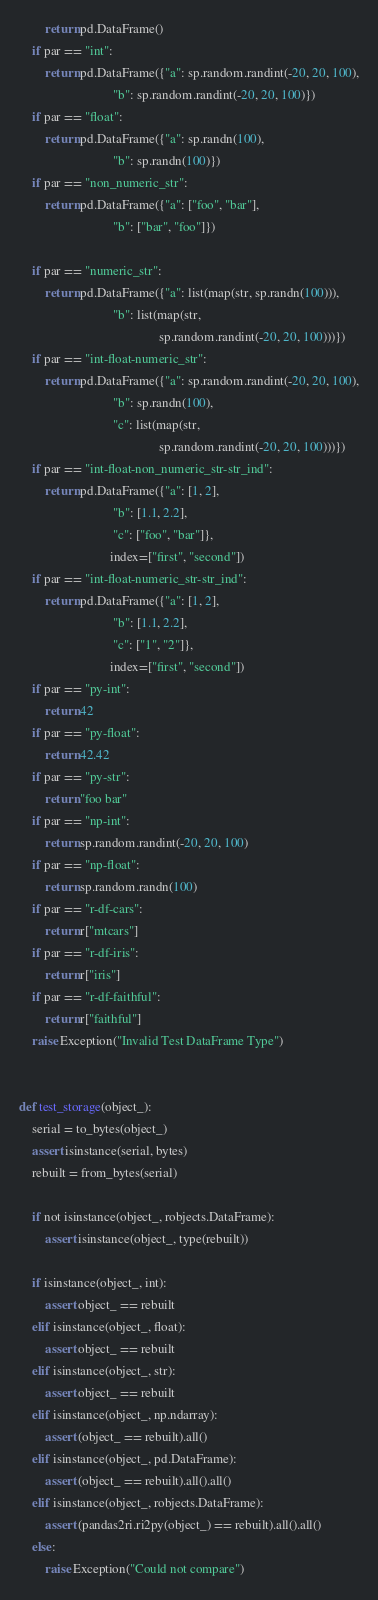<code> <loc_0><loc_0><loc_500><loc_500><_Python_>        return pd.DataFrame()
    if par == "int":
        return pd.DataFrame({"a": sp.random.randint(-20, 20, 100),
                             "b": sp.random.randint(-20, 20, 100)})
    if par == "float":
        return pd.DataFrame({"a": sp.randn(100),
                             "b": sp.randn(100)})
    if par == "non_numeric_str":
        return pd.DataFrame({"a": ["foo", "bar"],
                             "b": ["bar", "foo"]})

    if par == "numeric_str":
        return pd.DataFrame({"a": list(map(str, sp.randn(100))),
                             "b": list(map(str,
                                           sp.random.randint(-20, 20, 100)))})
    if par == "int-float-numeric_str":
        return pd.DataFrame({"a": sp.random.randint(-20, 20, 100),
                             "b": sp.randn(100),
                             "c": list(map(str,
                                           sp.random.randint(-20, 20, 100)))})
    if par == "int-float-non_numeric_str-str_ind":
        return pd.DataFrame({"a": [1, 2],
                             "b": [1.1, 2.2],
                             "c": ["foo", "bar"]},
                            index=["first", "second"])
    if par == "int-float-numeric_str-str_ind":
        return pd.DataFrame({"a": [1, 2],
                             "b": [1.1, 2.2],
                             "c": ["1", "2"]},
                            index=["first", "second"])
    if par == "py-int":
        return 42
    if par == "py-float":
        return 42.42
    if par == "py-str":
        return "foo bar"
    if par == "np-int":
        return sp.random.randint(-20, 20, 100)
    if par == "np-float":
        return sp.random.randn(100)
    if par == "r-df-cars":
        return r["mtcars"]
    if par == "r-df-iris":
        return r["iris"]
    if par == "r-df-faithful":
        return r["faithful"]
    raise Exception("Invalid Test DataFrame Type")


def test_storage(object_):
    serial = to_bytes(object_)
    assert isinstance(serial, bytes)
    rebuilt = from_bytes(serial)

    if not isinstance(object_, robjects.DataFrame):
        assert isinstance(object_, type(rebuilt))

    if isinstance(object_, int):
        assert object_ == rebuilt
    elif isinstance(object_, float):
        assert object_ == rebuilt
    elif isinstance(object_, str):
        assert object_ == rebuilt
    elif isinstance(object_, np.ndarray):
        assert (object_ == rebuilt).all()
    elif isinstance(object_, pd.DataFrame):
        assert (object_ == rebuilt).all().all()
    elif isinstance(object_, robjects.DataFrame):
        assert (pandas2ri.ri2py(object_) == rebuilt).all().all()
    else:
        raise Exception("Could not compare")
</code> 